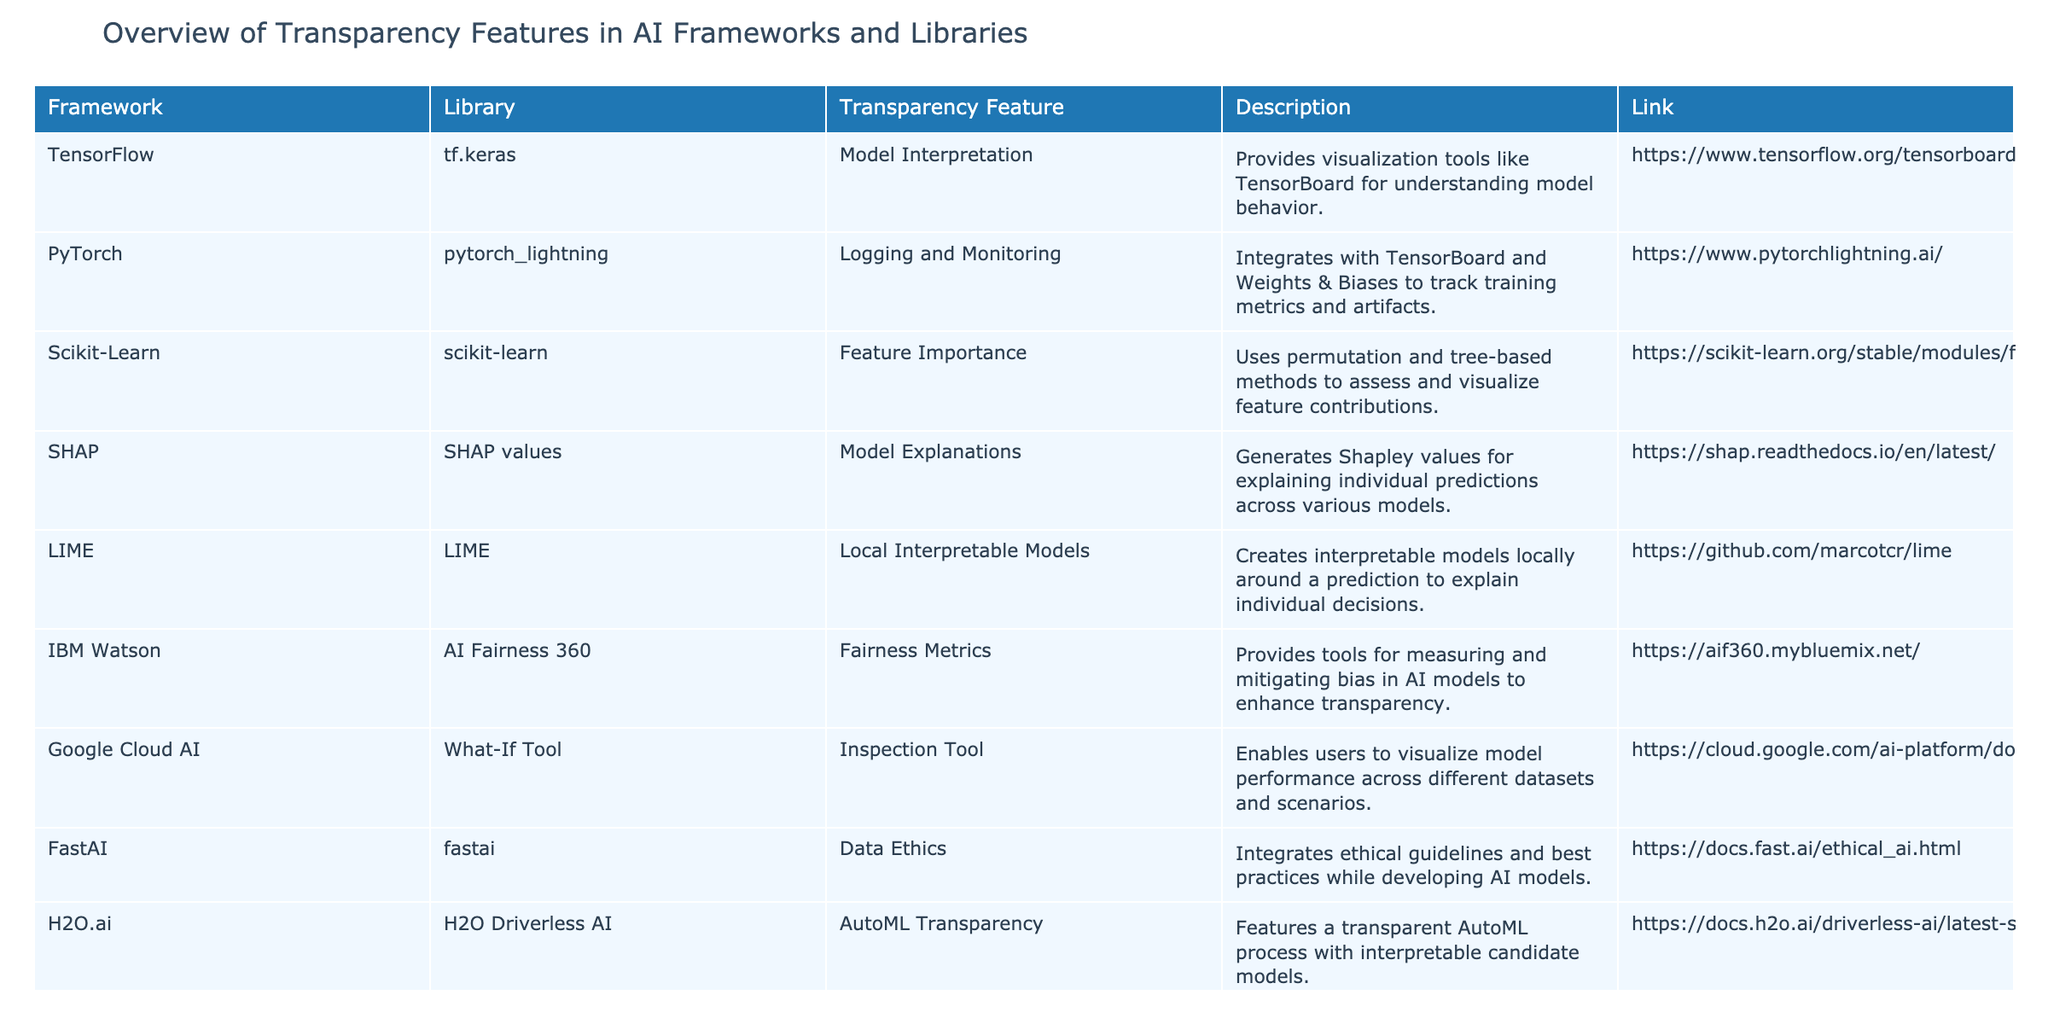What transparency feature is associated with TensorFlow? The table lists that TensorFlow, specifically in its tf.keras module, has a transparency feature called "Model Interpretation," which provides visualization tools like TensorBoard for understanding model behavior.
Answer: Model Interpretation Which library implements Local Interpretable Models? According to the table, the library implementing Local Interpretable Models is LIME.
Answer: LIME How many frameworks have features related to fairness? From the table, there are two frameworks that have a transparency feature related to fairness: IBM Watson with "Fairness Metrics" and Google Cloud AI with its "Inspection Tool" does not address fairness specifically; it focuses on model performance. Therefore, the answer is 1.
Answer: 1 What tool does Microsoft Azure offer for interpreting machine learning models? The table indicates that Microsoft Azure offers InterpretML for interpreting machine learning models.
Answer: InterpretML Is SHAP related to explaining individual predictions? The table mentions that SHAP values generate Shapley values for explaining individual predictions across various models, which confirms that it is indeed related to this aspect.
Answer: Yes Which framework provides transparency through AutoML processes? According to the table, H2O.ai provides transparency through its H2O Driverless AI, which features a transparent AutoML process with interpretable candidate models.
Answer: H2O Driverless AI What type of transparency feature does Google Cloud AI primarily focus on? The table shows that Google Cloud AI's transparency feature, the What-If Tool, is an inspection tool. This indicates that its primary focus is on inspecting model performance across different datasets and scenarios.
Answer: Inspection Tool Which feature provides ethical guidelines in AI frameworks? FastAI is indicated in the table as integrating ethical guidelines and best practices while developing AI models, thus providing this feature.
Answer: Data Ethics Identify all frameworks that provide visualization tools for understanding model behavior. The table shows that TensorFlow (tf.keras with Model Interpretation) and SHAP (SHAP values) provide visualization tools for understanding model behavior. Therefore, the identified frameworks are TensorFlow and SHAP.
Answer: TensorFlow, SHAP How does the transparency feature of IBM Watson enhance AI model transparency? The table explains that IBM Watson provides "Fairness Metrics," aiming to measure and mitigate bias in AI models. This enhances transparency by ensuring fairness in model performance and decision-making.
Answer: By measuring and mitigating bias 